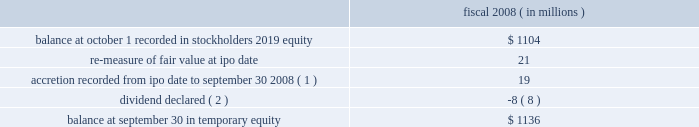Visa inc .
Notes to consolidated financial statements 2014 ( continued ) september 30 , 2008 ( in millions , except as noted ) the company redeemed all outstanding shares of class c ( series ii ) common stock in october 2008 at its redemption price of $ 1.136 billion , which represents its stated redemption price of $ 1.146 billion reduced by the dividend declared in june 2008 and paid on these shares in august 2008 and the extinguishment of the subscription receivable .
Fair value and accretion of class c ( series ii ) common stock at the time of the reorganization in october 2007 , the company determined the fair value of the class c ( series ii ) common stock to be approximately $ 1.104 billion .
Prior to the ipo these shares were not redeemable .
Completion of the company 2019s ipo triggered the redemption feature of this stock .
As a result , in accordance with emerging issues task force ( 201ceitf 201d ) topic d-98 , 201cclassification and measurement of redeemable securities , 201d in march 2008 , the company reclassified all outstanding shares of the class c ( series ii ) common stock at its then fair value of $ 1.125 billion to temporary or mezzanine level equity on the company 2019s consolidated balance sheet with a corresponding reduction in additional paid-in-capital of $ 1.104 billion and accumulated income of $ 21 million .
Over the period from march 2008 to october 10 , 2008 , the date these shares were redeemed , the company recorded accretion of this stock to its redemption price through accumulated income .
The table reflects activity related to the class c ( series ii ) common stock from october 1 , 2007 to september 30 , 2008 : fiscal 2008 ( in millions ) .
( 1 ) over the period from march 2008 to september 30 , 2008 , the company recorded accretion of this stock to its redemption price through accumulated income .
( 2 ) in june 2008 , the company declared a dividend of $ 0.105 per share .
The dividend paid to the class c ( series ii ) common stock is treated as a reduction in temporary equity as it reduces the redemption value of the class c ( series ii ) common stock .
See note 16 2014stockholders 2019 equity and redeemable shares for further information regarding the dividend declaration .
October 2008 redemptions of class c ( series ii ) and class c ( series iii ) common stock as noted above , on october 10 , 2008 , the company redeemed all of the outstanding shares of class c ( series ii ) common stock at its redemption price of $ 1.146 billion less dividends paid , or $ 1.136 billion .
Pursuant to the company 2019s fourth amended and restated certificate of incorporation , 35263585 shares of class c ( series iii ) common stock were required to be redeemed in october 2008 and therefore were classified as a current liability at september 30 , 2008 on the company 2019s consolidated balance sheet .
On october 10 , 2008 , the company used $ 1.508 billion of net proceeds from the ipo for the required redemption of 35263585 shares of class c ( series iii ) common stock at a redemption .
What amount of dividend was was paid to class c series ii and series iii common stock holders , ( in billions ) ?\\n? 
Computations: (1.146 - 1.136)
Answer: 0.01. Visa inc .
Notes to consolidated financial statements 2014 ( continued ) september 30 , 2008 ( in millions , except as noted ) the company redeemed all outstanding shares of class c ( series ii ) common stock in october 2008 at its redemption price of $ 1.136 billion , which represents its stated redemption price of $ 1.146 billion reduced by the dividend declared in june 2008 and paid on these shares in august 2008 and the extinguishment of the subscription receivable .
Fair value and accretion of class c ( series ii ) common stock at the time of the reorganization in october 2007 , the company determined the fair value of the class c ( series ii ) common stock to be approximately $ 1.104 billion .
Prior to the ipo these shares were not redeemable .
Completion of the company 2019s ipo triggered the redemption feature of this stock .
As a result , in accordance with emerging issues task force ( 201ceitf 201d ) topic d-98 , 201cclassification and measurement of redeemable securities , 201d in march 2008 , the company reclassified all outstanding shares of the class c ( series ii ) common stock at its then fair value of $ 1.125 billion to temporary or mezzanine level equity on the company 2019s consolidated balance sheet with a corresponding reduction in additional paid-in-capital of $ 1.104 billion and accumulated income of $ 21 million .
Over the period from march 2008 to october 10 , 2008 , the date these shares were redeemed , the company recorded accretion of this stock to its redemption price through accumulated income .
The table reflects activity related to the class c ( series ii ) common stock from october 1 , 2007 to september 30 , 2008 : fiscal 2008 ( in millions ) .
( 1 ) over the period from march 2008 to september 30 , 2008 , the company recorded accretion of this stock to its redemption price through accumulated income .
( 2 ) in june 2008 , the company declared a dividend of $ 0.105 per share .
The dividend paid to the class c ( series ii ) common stock is treated as a reduction in temporary equity as it reduces the redemption value of the class c ( series ii ) common stock .
See note 16 2014stockholders 2019 equity and redeemable shares for further information regarding the dividend declaration .
October 2008 redemptions of class c ( series ii ) and class c ( series iii ) common stock as noted above , on october 10 , 2008 , the company redeemed all of the outstanding shares of class c ( series ii ) common stock at its redemption price of $ 1.146 billion less dividends paid , or $ 1.136 billion .
Pursuant to the company 2019s fourth amended and restated certificate of incorporation , 35263585 shares of class c ( series iii ) common stock were required to be redeemed in october 2008 and therefore were classified as a current liability at september 30 , 2008 on the company 2019s consolidated balance sheet .
On october 10 , 2008 , the company used $ 1.508 billion of net proceeds from the ipo for the required redemption of 35263585 shares of class c ( series iii ) common stock at a redemption .
What is the net chance in activity related to the class c ( series ii ) common stock from october 1 , 2007 to september 30 , 2008 , ( in millions ) ? 
Computations: (1136 - 1104)
Answer: 32.0. 